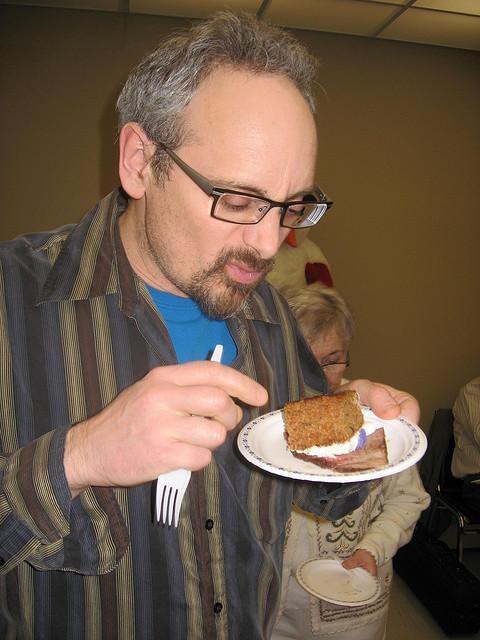How many people are there?
Give a very brief answer. 3. How many birds are there?
Give a very brief answer. 0. 